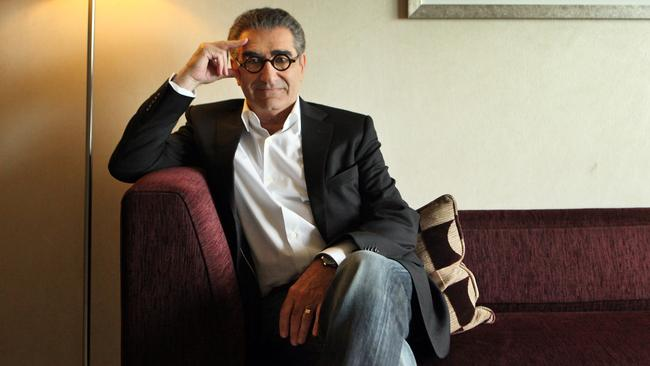Analyze the image in a comprehensive and detailed manner.
 In this image, the renowned actor Eugene Levy is captured in a moment of contemplation. He is comfortably seated on a purple couch, his legs crossed and his left hand resting on his knee. Dressed in a smart black suit jacket, a crisp white collared shirt, and casual blue jeans, he exudes an air of relaxed sophistication. His signature glasses are perched on his nose, and a slight smile plays on his lips, hinting at an inner amusement. His right hand is raised to his forehead, suggesting deep thought or perhaps a moment of introspection. Beside him on the couch is a beige pillow adorned with a brown geometric pattern, adding a touch of homely comfort to the scene. The backdrop is a simple beige wall, adorned with a framed painting that adds an artistic touch to the overall setting. 